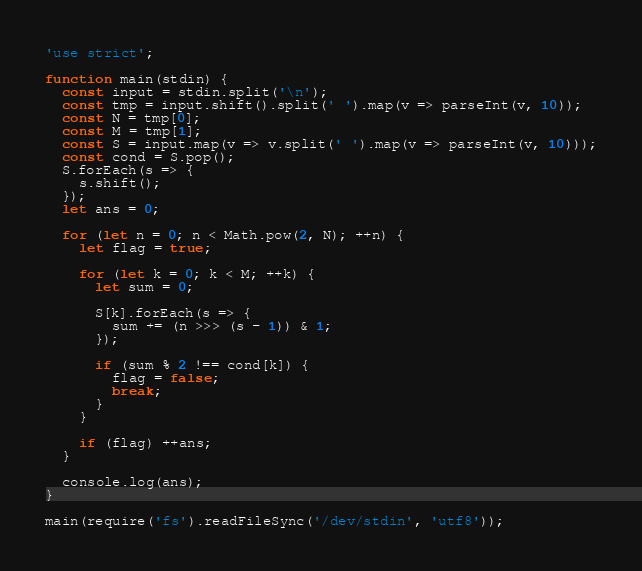<code> <loc_0><loc_0><loc_500><loc_500><_JavaScript_>'use strict';

function main(stdin) {
  const input = stdin.split('\n');
  const tmp = input.shift().split(' ').map(v => parseInt(v, 10));
  const N = tmp[0];
  const M = tmp[1];
  const S = input.map(v => v.split(' ').map(v => parseInt(v, 10)));
  const cond = S.pop();
  S.forEach(s => {
    s.shift();
  });
  let ans = 0;

  for (let n = 0; n < Math.pow(2, N); ++n) {
    let flag = true;

    for (let k = 0; k < M; ++k) {
      let sum = 0;

      S[k].forEach(s => {
        sum += (n >>> (s - 1)) & 1;
      });

      if (sum % 2 !== cond[k]) {
        flag = false;
        break;
      }
    }

    if (flag) ++ans;
  }
  
  console.log(ans);
}

main(require('fs').readFileSync('/dev/stdin', 'utf8'));</code> 